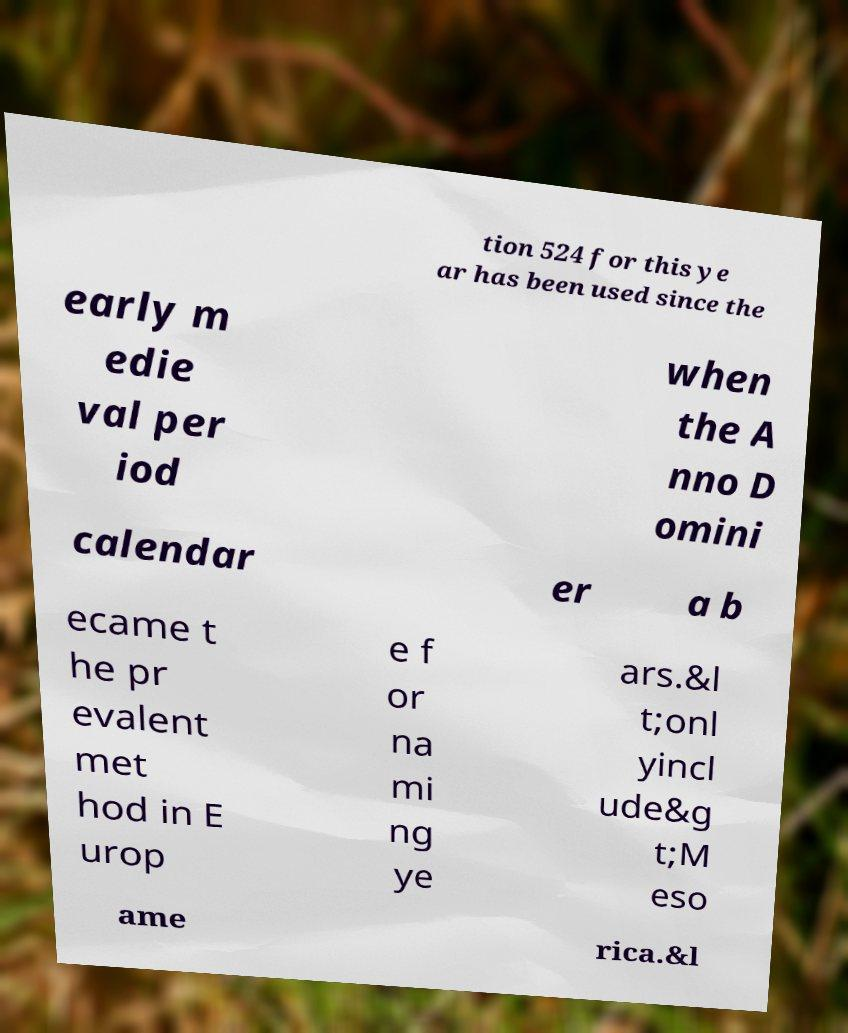For documentation purposes, I need the text within this image transcribed. Could you provide that? tion 524 for this ye ar has been used since the early m edie val per iod when the A nno D omini calendar er a b ecame t he pr evalent met hod in E urop e f or na mi ng ye ars.&l t;onl yincl ude&g t;M eso ame rica.&l 